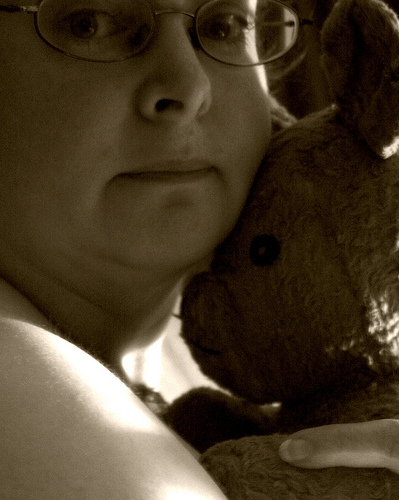<image>
Is there a woman under the woman? No. The woman is not positioned under the woman. The vertical relationship between these objects is different. 